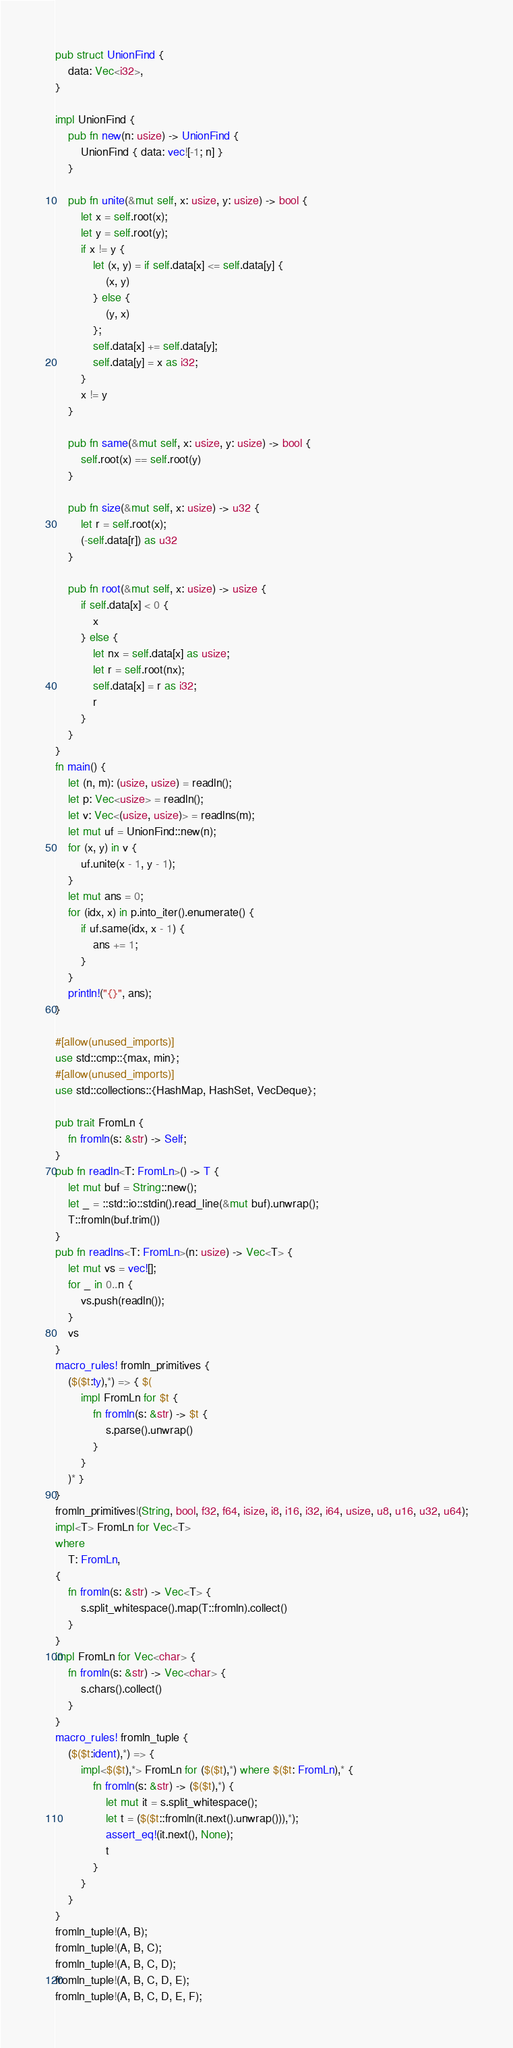Convert code to text. <code><loc_0><loc_0><loc_500><loc_500><_Rust_>pub struct UnionFind {
    data: Vec<i32>,
}

impl UnionFind {
    pub fn new(n: usize) -> UnionFind {
        UnionFind { data: vec![-1; n] }
    }

    pub fn unite(&mut self, x: usize, y: usize) -> bool {
        let x = self.root(x);
        let y = self.root(y);
        if x != y {
            let (x, y) = if self.data[x] <= self.data[y] {
                (x, y)
            } else {
                (y, x)
            };
            self.data[x] += self.data[y];
            self.data[y] = x as i32;
        }
        x != y
    }

    pub fn same(&mut self, x: usize, y: usize) -> bool {
        self.root(x) == self.root(y)
    }

    pub fn size(&mut self, x: usize) -> u32 {
        let r = self.root(x);
        (-self.data[r]) as u32
    }

    pub fn root(&mut self, x: usize) -> usize {
        if self.data[x] < 0 {
            x
        } else {
            let nx = self.data[x] as usize;
            let r = self.root(nx);
            self.data[x] = r as i32;
            r
        }
    }
}
fn main() {
    let (n, m): (usize, usize) = readln();
    let p: Vec<usize> = readln();
    let v: Vec<(usize, usize)> = readlns(m);
    let mut uf = UnionFind::new(n);
    for (x, y) in v {
        uf.unite(x - 1, y - 1);
    }
    let mut ans = 0;
    for (idx, x) in p.into_iter().enumerate() {
        if uf.same(idx, x - 1) {
            ans += 1;
        }
    }
    println!("{}", ans);
}

#[allow(unused_imports)]
use std::cmp::{max, min};
#[allow(unused_imports)]
use std::collections::{HashMap, HashSet, VecDeque};

pub trait FromLn {
    fn fromln(s: &str) -> Self;
}
pub fn readln<T: FromLn>() -> T {
    let mut buf = String::new();
    let _ = ::std::io::stdin().read_line(&mut buf).unwrap();
    T::fromln(buf.trim())
}
pub fn readlns<T: FromLn>(n: usize) -> Vec<T> {
    let mut vs = vec![];
    for _ in 0..n {
        vs.push(readln());
    }
    vs
}
macro_rules! fromln_primitives {
    ($($t:ty),*) => { $(
        impl FromLn for $t {
            fn fromln(s: &str) -> $t {
                s.parse().unwrap()
            }
        }
    )* }
}
fromln_primitives!(String, bool, f32, f64, isize, i8, i16, i32, i64, usize, u8, u16, u32, u64);
impl<T> FromLn for Vec<T>
where
    T: FromLn,
{
    fn fromln(s: &str) -> Vec<T> {
        s.split_whitespace().map(T::fromln).collect()
    }
}
impl FromLn for Vec<char> {
    fn fromln(s: &str) -> Vec<char> {
        s.chars().collect()
    }
}
macro_rules! fromln_tuple {
    ($($t:ident),*) => {
        impl<$($t),*> FromLn for ($($t),*) where $($t: FromLn),* {
            fn fromln(s: &str) -> ($($t),*) {
                let mut it = s.split_whitespace();
                let t = ($($t::fromln(it.next().unwrap())),*);
                assert_eq!(it.next(), None);
                t
            }
        }
    }
}
fromln_tuple!(A, B);
fromln_tuple!(A, B, C);
fromln_tuple!(A, B, C, D);
fromln_tuple!(A, B, C, D, E);
fromln_tuple!(A, B, C, D, E, F);
</code> 